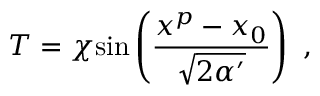Convert formula to latex. <formula><loc_0><loc_0><loc_500><loc_500>T = \chi \sin \left ( { \frac { x ^ { p } - x _ { 0 } } { \sqrt { 2 \alpha ^ { \prime } } } } \right ) \ ,</formula> 